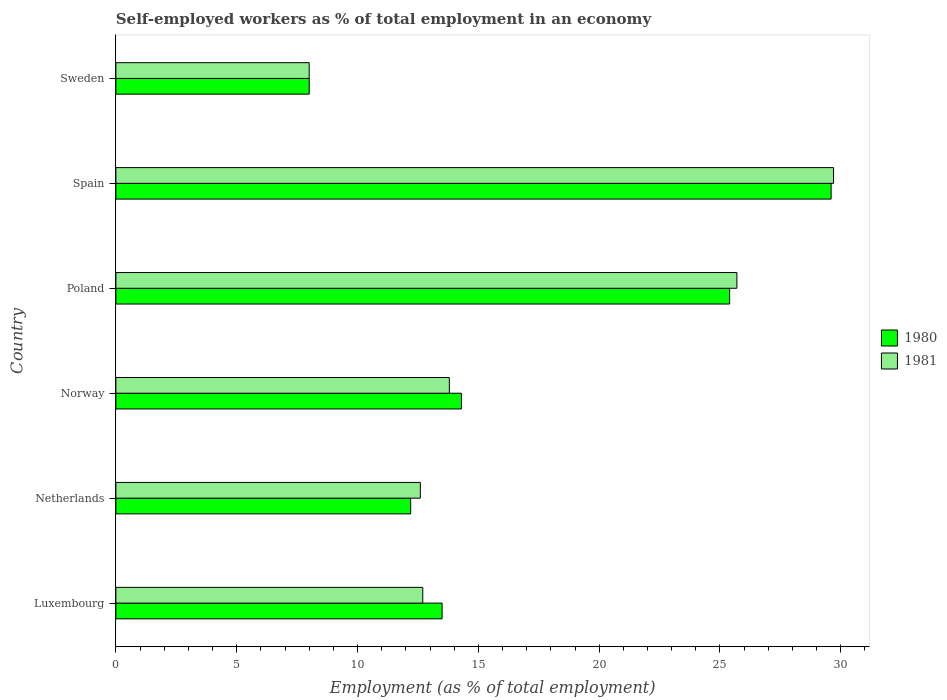How many groups of bars are there?
Give a very brief answer. 6. Are the number of bars per tick equal to the number of legend labels?
Make the answer very short. Yes. Are the number of bars on each tick of the Y-axis equal?
Keep it short and to the point. Yes. How many bars are there on the 4th tick from the top?
Your answer should be very brief. 2. In how many cases, is the number of bars for a given country not equal to the number of legend labels?
Your answer should be compact. 0. What is the percentage of self-employed workers in 1981 in Poland?
Keep it short and to the point. 25.7. Across all countries, what is the maximum percentage of self-employed workers in 1981?
Make the answer very short. 29.7. Across all countries, what is the minimum percentage of self-employed workers in 1981?
Your answer should be compact. 8. In which country was the percentage of self-employed workers in 1981 maximum?
Ensure brevity in your answer.  Spain. In which country was the percentage of self-employed workers in 1981 minimum?
Give a very brief answer. Sweden. What is the total percentage of self-employed workers in 1980 in the graph?
Offer a terse response. 103. What is the difference between the percentage of self-employed workers in 1980 in Luxembourg and that in Spain?
Your answer should be compact. -16.1. What is the difference between the percentage of self-employed workers in 1980 in Spain and the percentage of self-employed workers in 1981 in Netherlands?
Provide a short and direct response. 17. What is the average percentage of self-employed workers in 1980 per country?
Your answer should be compact. 17.17. What is the difference between the percentage of self-employed workers in 1980 and percentage of self-employed workers in 1981 in Netherlands?
Your response must be concise. -0.4. What is the ratio of the percentage of self-employed workers in 1980 in Netherlands to that in Norway?
Provide a succinct answer. 0.85. Is the percentage of self-employed workers in 1980 in Netherlands less than that in Norway?
Provide a short and direct response. Yes. Is the difference between the percentage of self-employed workers in 1980 in Netherlands and Sweden greater than the difference between the percentage of self-employed workers in 1981 in Netherlands and Sweden?
Offer a terse response. No. What is the difference between the highest and the second highest percentage of self-employed workers in 1980?
Make the answer very short. 4.2. What is the difference between the highest and the lowest percentage of self-employed workers in 1981?
Provide a succinct answer. 21.7. Is the sum of the percentage of self-employed workers in 1981 in Luxembourg and Poland greater than the maximum percentage of self-employed workers in 1980 across all countries?
Provide a short and direct response. Yes. What does the 1st bar from the top in Poland represents?
Your response must be concise. 1981. What does the 2nd bar from the bottom in Spain represents?
Offer a very short reply. 1981. How many countries are there in the graph?
Give a very brief answer. 6. Does the graph contain any zero values?
Your response must be concise. No. Where does the legend appear in the graph?
Provide a succinct answer. Center right. How many legend labels are there?
Give a very brief answer. 2. How are the legend labels stacked?
Provide a succinct answer. Vertical. What is the title of the graph?
Provide a succinct answer. Self-employed workers as % of total employment in an economy. What is the label or title of the X-axis?
Give a very brief answer. Employment (as % of total employment). What is the Employment (as % of total employment) in 1981 in Luxembourg?
Your answer should be very brief. 12.7. What is the Employment (as % of total employment) of 1980 in Netherlands?
Provide a succinct answer. 12.2. What is the Employment (as % of total employment) of 1981 in Netherlands?
Your answer should be very brief. 12.6. What is the Employment (as % of total employment) of 1980 in Norway?
Your answer should be very brief. 14.3. What is the Employment (as % of total employment) of 1981 in Norway?
Offer a terse response. 13.8. What is the Employment (as % of total employment) in 1980 in Poland?
Keep it short and to the point. 25.4. What is the Employment (as % of total employment) in 1981 in Poland?
Give a very brief answer. 25.7. What is the Employment (as % of total employment) in 1980 in Spain?
Provide a succinct answer. 29.6. What is the Employment (as % of total employment) of 1981 in Spain?
Your response must be concise. 29.7. Across all countries, what is the maximum Employment (as % of total employment) of 1980?
Provide a short and direct response. 29.6. Across all countries, what is the maximum Employment (as % of total employment) of 1981?
Keep it short and to the point. 29.7. What is the total Employment (as % of total employment) in 1980 in the graph?
Provide a short and direct response. 103. What is the total Employment (as % of total employment) in 1981 in the graph?
Offer a very short reply. 102.5. What is the difference between the Employment (as % of total employment) of 1981 in Luxembourg and that in Netherlands?
Your response must be concise. 0.1. What is the difference between the Employment (as % of total employment) in 1980 in Luxembourg and that in Spain?
Make the answer very short. -16.1. What is the difference between the Employment (as % of total employment) in 1981 in Luxembourg and that in Spain?
Make the answer very short. -17. What is the difference between the Employment (as % of total employment) of 1980 in Luxembourg and that in Sweden?
Provide a succinct answer. 5.5. What is the difference between the Employment (as % of total employment) in 1980 in Netherlands and that in Spain?
Provide a short and direct response. -17.4. What is the difference between the Employment (as % of total employment) of 1981 in Netherlands and that in Spain?
Offer a terse response. -17.1. What is the difference between the Employment (as % of total employment) of 1980 in Norway and that in Poland?
Provide a short and direct response. -11.1. What is the difference between the Employment (as % of total employment) in 1981 in Norway and that in Poland?
Your answer should be very brief. -11.9. What is the difference between the Employment (as % of total employment) in 1980 in Norway and that in Spain?
Offer a terse response. -15.3. What is the difference between the Employment (as % of total employment) of 1981 in Norway and that in Spain?
Provide a short and direct response. -15.9. What is the difference between the Employment (as % of total employment) of 1980 in Poland and that in Sweden?
Make the answer very short. 17.4. What is the difference between the Employment (as % of total employment) in 1980 in Spain and that in Sweden?
Your answer should be compact. 21.6. What is the difference between the Employment (as % of total employment) of 1981 in Spain and that in Sweden?
Give a very brief answer. 21.7. What is the difference between the Employment (as % of total employment) in 1980 in Luxembourg and the Employment (as % of total employment) in 1981 in Netherlands?
Provide a short and direct response. 0.9. What is the difference between the Employment (as % of total employment) of 1980 in Luxembourg and the Employment (as % of total employment) of 1981 in Norway?
Ensure brevity in your answer.  -0.3. What is the difference between the Employment (as % of total employment) of 1980 in Luxembourg and the Employment (as % of total employment) of 1981 in Poland?
Make the answer very short. -12.2. What is the difference between the Employment (as % of total employment) in 1980 in Luxembourg and the Employment (as % of total employment) in 1981 in Spain?
Provide a short and direct response. -16.2. What is the difference between the Employment (as % of total employment) of 1980 in Netherlands and the Employment (as % of total employment) of 1981 in Spain?
Provide a succinct answer. -17.5. What is the difference between the Employment (as % of total employment) in 1980 in Norway and the Employment (as % of total employment) in 1981 in Spain?
Give a very brief answer. -15.4. What is the difference between the Employment (as % of total employment) of 1980 in Norway and the Employment (as % of total employment) of 1981 in Sweden?
Ensure brevity in your answer.  6.3. What is the difference between the Employment (as % of total employment) of 1980 in Spain and the Employment (as % of total employment) of 1981 in Sweden?
Offer a very short reply. 21.6. What is the average Employment (as % of total employment) of 1980 per country?
Ensure brevity in your answer.  17.17. What is the average Employment (as % of total employment) of 1981 per country?
Provide a short and direct response. 17.08. What is the difference between the Employment (as % of total employment) of 1980 and Employment (as % of total employment) of 1981 in Luxembourg?
Provide a short and direct response. 0.8. What is the difference between the Employment (as % of total employment) of 1980 and Employment (as % of total employment) of 1981 in Netherlands?
Ensure brevity in your answer.  -0.4. What is the difference between the Employment (as % of total employment) in 1980 and Employment (as % of total employment) in 1981 in Norway?
Offer a terse response. 0.5. What is the difference between the Employment (as % of total employment) in 1980 and Employment (as % of total employment) in 1981 in Spain?
Provide a succinct answer. -0.1. What is the difference between the Employment (as % of total employment) of 1980 and Employment (as % of total employment) of 1981 in Sweden?
Provide a short and direct response. 0. What is the ratio of the Employment (as % of total employment) in 1980 in Luxembourg to that in Netherlands?
Your answer should be very brief. 1.11. What is the ratio of the Employment (as % of total employment) in 1981 in Luxembourg to that in Netherlands?
Offer a very short reply. 1.01. What is the ratio of the Employment (as % of total employment) of 1980 in Luxembourg to that in Norway?
Give a very brief answer. 0.94. What is the ratio of the Employment (as % of total employment) in 1981 in Luxembourg to that in Norway?
Offer a terse response. 0.92. What is the ratio of the Employment (as % of total employment) in 1980 in Luxembourg to that in Poland?
Give a very brief answer. 0.53. What is the ratio of the Employment (as % of total employment) of 1981 in Luxembourg to that in Poland?
Offer a terse response. 0.49. What is the ratio of the Employment (as % of total employment) in 1980 in Luxembourg to that in Spain?
Your answer should be very brief. 0.46. What is the ratio of the Employment (as % of total employment) of 1981 in Luxembourg to that in Spain?
Provide a succinct answer. 0.43. What is the ratio of the Employment (as % of total employment) of 1980 in Luxembourg to that in Sweden?
Offer a terse response. 1.69. What is the ratio of the Employment (as % of total employment) in 1981 in Luxembourg to that in Sweden?
Your response must be concise. 1.59. What is the ratio of the Employment (as % of total employment) of 1980 in Netherlands to that in Norway?
Provide a succinct answer. 0.85. What is the ratio of the Employment (as % of total employment) in 1980 in Netherlands to that in Poland?
Make the answer very short. 0.48. What is the ratio of the Employment (as % of total employment) of 1981 in Netherlands to that in Poland?
Your response must be concise. 0.49. What is the ratio of the Employment (as % of total employment) of 1980 in Netherlands to that in Spain?
Give a very brief answer. 0.41. What is the ratio of the Employment (as % of total employment) in 1981 in Netherlands to that in Spain?
Provide a short and direct response. 0.42. What is the ratio of the Employment (as % of total employment) of 1980 in Netherlands to that in Sweden?
Ensure brevity in your answer.  1.52. What is the ratio of the Employment (as % of total employment) of 1981 in Netherlands to that in Sweden?
Ensure brevity in your answer.  1.57. What is the ratio of the Employment (as % of total employment) of 1980 in Norway to that in Poland?
Offer a very short reply. 0.56. What is the ratio of the Employment (as % of total employment) of 1981 in Norway to that in Poland?
Offer a very short reply. 0.54. What is the ratio of the Employment (as % of total employment) of 1980 in Norway to that in Spain?
Your answer should be compact. 0.48. What is the ratio of the Employment (as % of total employment) of 1981 in Norway to that in Spain?
Provide a short and direct response. 0.46. What is the ratio of the Employment (as % of total employment) in 1980 in Norway to that in Sweden?
Your answer should be very brief. 1.79. What is the ratio of the Employment (as % of total employment) in 1981 in Norway to that in Sweden?
Give a very brief answer. 1.73. What is the ratio of the Employment (as % of total employment) of 1980 in Poland to that in Spain?
Provide a short and direct response. 0.86. What is the ratio of the Employment (as % of total employment) in 1981 in Poland to that in Spain?
Give a very brief answer. 0.87. What is the ratio of the Employment (as % of total employment) of 1980 in Poland to that in Sweden?
Your response must be concise. 3.17. What is the ratio of the Employment (as % of total employment) in 1981 in Poland to that in Sweden?
Keep it short and to the point. 3.21. What is the ratio of the Employment (as % of total employment) of 1981 in Spain to that in Sweden?
Offer a terse response. 3.71. What is the difference between the highest and the second highest Employment (as % of total employment) in 1980?
Ensure brevity in your answer.  4.2. What is the difference between the highest and the second highest Employment (as % of total employment) of 1981?
Provide a succinct answer. 4. What is the difference between the highest and the lowest Employment (as % of total employment) of 1980?
Offer a very short reply. 21.6. What is the difference between the highest and the lowest Employment (as % of total employment) of 1981?
Keep it short and to the point. 21.7. 